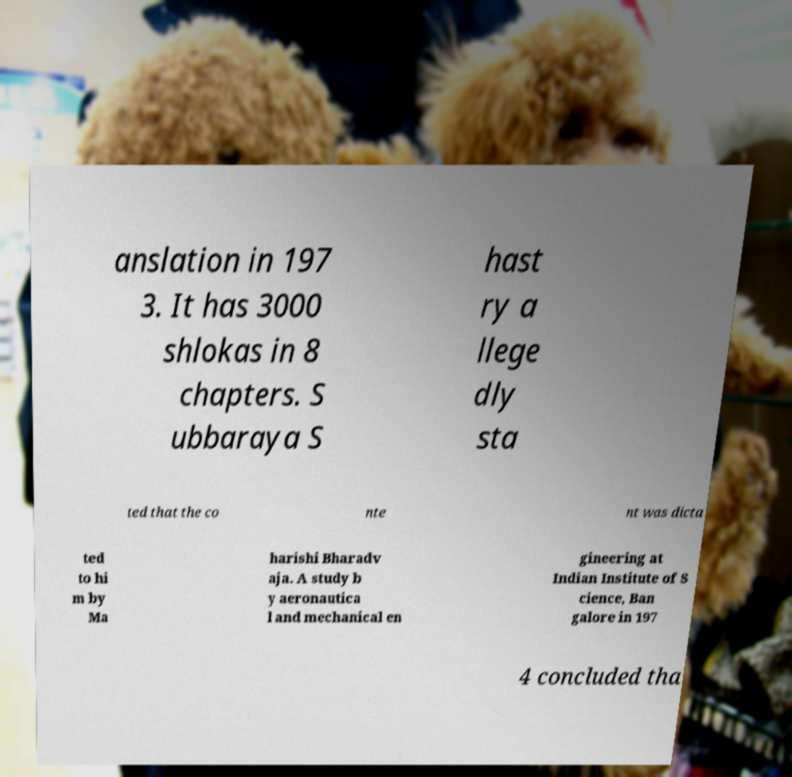I need the written content from this picture converted into text. Can you do that? anslation in 197 3. It has 3000 shlokas in 8 chapters. S ubbaraya S hast ry a llege dly sta ted that the co nte nt was dicta ted to hi m by Ma harishi Bharadv aja. A study b y aeronautica l and mechanical en gineering at Indian Institute of S cience, Ban galore in 197 4 concluded tha 